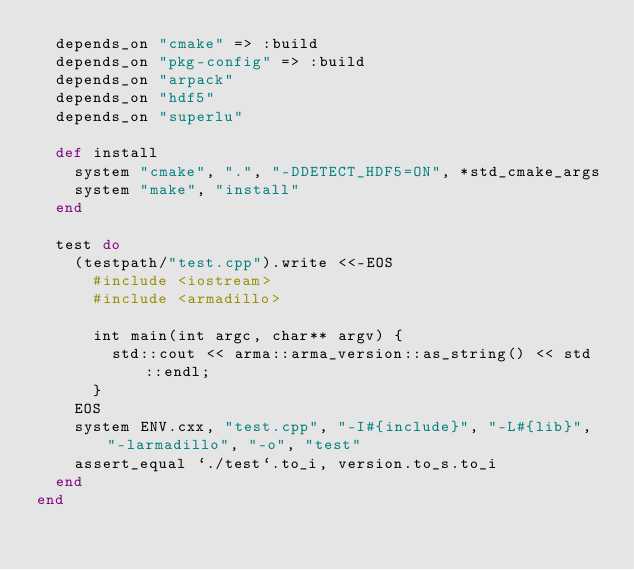Convert code to text. <code><loc_0><loc_0><loc_500><loc_500><_Ruby_>  depends_on "cmake" => :build
  depends_on "pkg-config" => :build
  depends_on "arpack"
  depends_on "hdf5"
  depends_on "superlu"

  def install
    system "cmake", ".", "-DDETECT_HDF5=ON", *std_cmake_args
    system "make", "install"
  end

  test do
    (testpath/"test.cpp").write <<-EOS
      #include <iostream>
      #include <armadillo>

      int main(int argc, char** argv) {
        std::cout << arma::arma_version::as_string() << std::endl;
      }
    EOS
    system ENV.cxx, "test.cpp", "-I#{include}", "-L#{lib}", "-larmadillo", "-o", "test"
    assert_equal `./test`.to_i, version.to_s.to_i
  end
end
</code> 